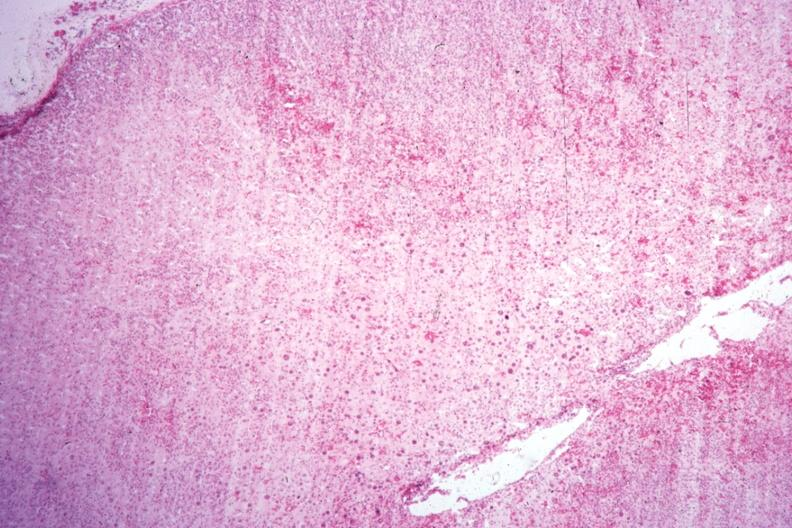s fibrotic lesion present?
Answer the question using a single word or phrase. No 